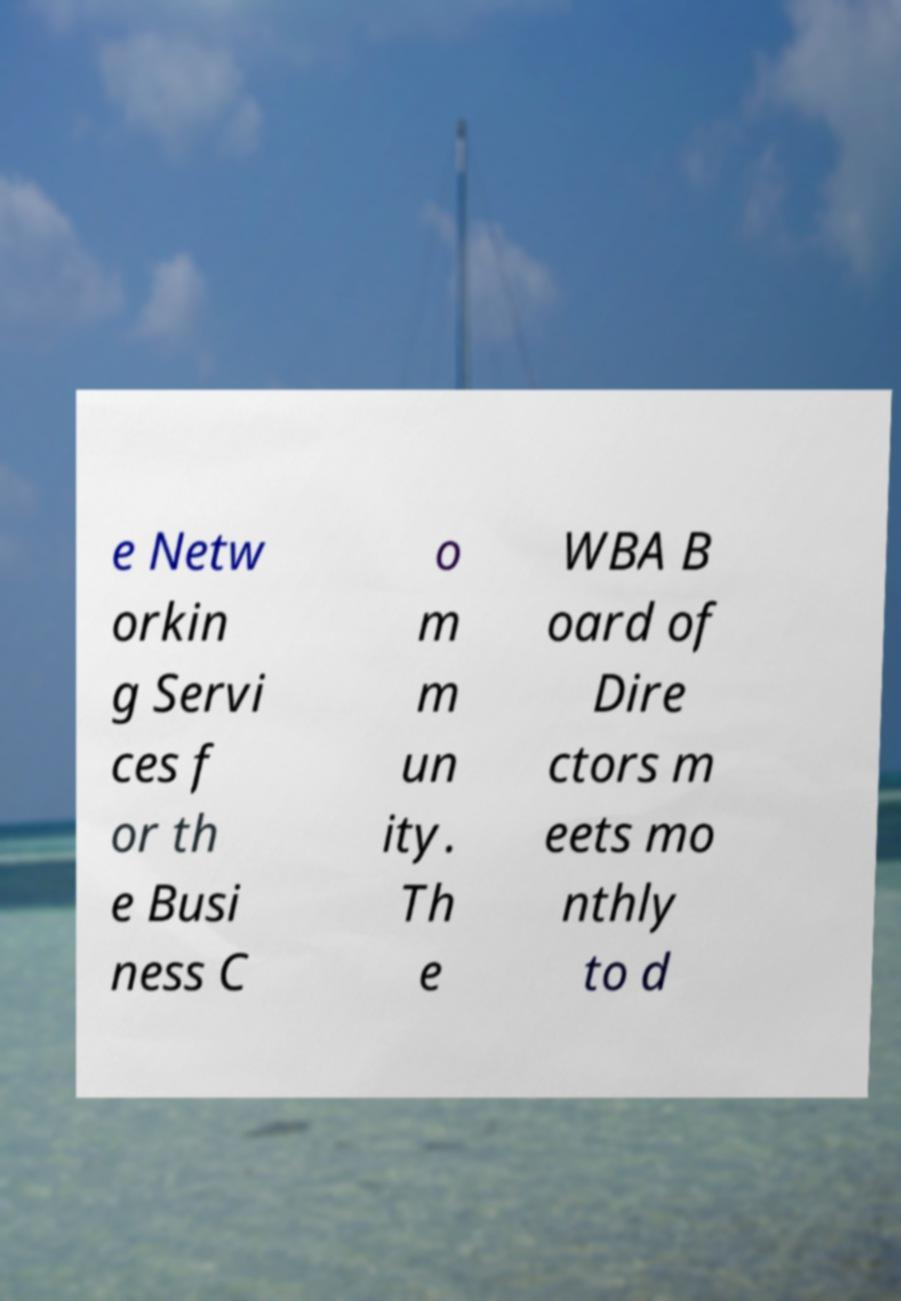Please read and relay the text visible in this image. What does it say? e Netw orkin g Servi ces f or th e Busi ness C o m m un ity. Th e WBA B oard of Dire ctors m eets mo nthly to d 